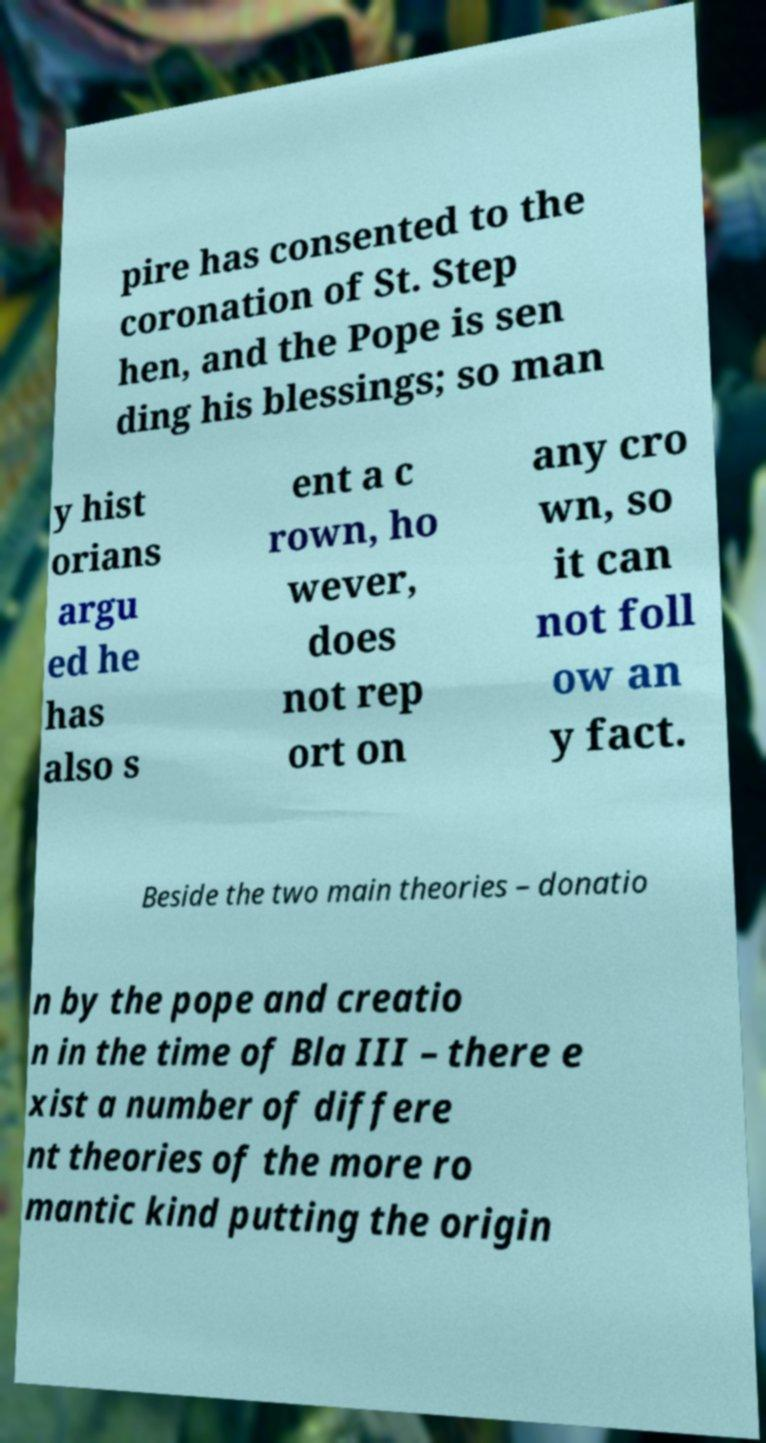I need the written content from this picture converted into text. Can you do that? pire has consented to the coronation of St. Step hen, and the Pope is sen ding his blessings; so man y hist orians argu ed he has also s ent a c rown, ho wever, does not rep ort on any cro wn, so it can not foll ow an y fact. Beside the two main theories – donatio n by the pope and creatio n in the time of Bla III – there e xist a number of differe nt theories of the more ro mantic kind putting the origin 